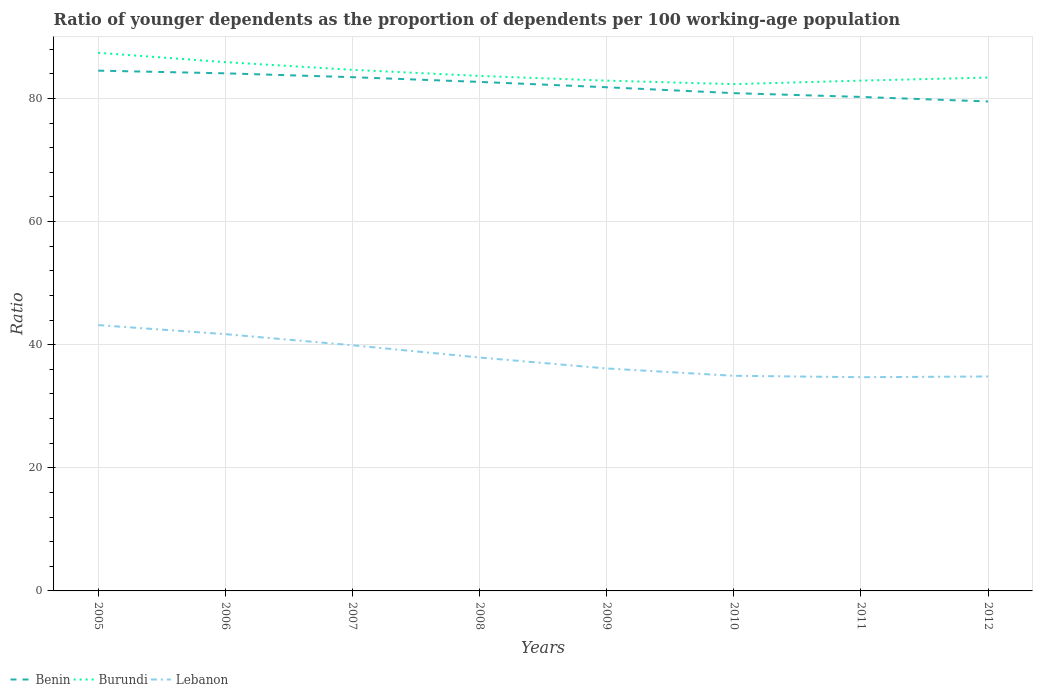Does the line corresponding to Burundi intersect with the line corresponding to Lebanon?
Offer a very short reply. No. Across all years, what is the maximum age dependency ratio(young) in Burundi?
Offer a terse response. 82.32. In which year was the age dependency ratio(young) in Lebanon maximum?
Provide a short and direct response. 2011. What is the total age dependency ratio(young) in Benin in the graph?
Your answer should be very brief. 2.59. What is the difference between the highest and the second highest age dependency ratio(young) in Lebanon?
Provide a succinct answer. 8.46. What is the difference between the highest and the lowest age dependency ratio(young) in Lebanon?
Provide a succinct answer. 3. Is the age dependency ratio(young) in Lebanon strictly greater than the age dependency ratio(young) in Benin over the years?
Provide a succinct answer. Yes. What is the difference between two consecutive major ticks on the Y-axis?
Provide a succinct answer. 20. Are the values on the major ticks of Y-axis written in scientific E-notation?
Offer a very short reply. No. Does the graph contain any zero values?
Your answer should be very brief. No. Does the graph contain grids?
Provide a short and direct response. Yes. How many legend labels are there?
Provide a succinct answer. 3. What is the title of the graph?
Give a very brief answer. Ratio of younger dependents as the proportion of dependents per 100 working-age population. What is the label or title of the Y-axis?
Your response must be concise. Ratio. What is the Ratio of Benin in 2005?
Make the answer very short. 84.52. What is the Ratio of Burundi in 2005?
Provide a succinct answer. 87.41. What is the Ratio in Lebanon in 2005?
Provide a succinct answer. 43.18. What is the Ratio in Benin in 2006?
Offer a terse response. 84.08. What is the Ratio in Burundi in 2006?
Give a very brief answer. 85.9. What is the Ratio of Lebanon in 2006?
Ensure brevity in your answer.  41.71. What is the Ratio in Benin in 2007?
Provide a short and direct response. 83.45. What is the Ratio of Burundi in 2007?
Offer a very short reply. 84.65. What is the Ratio of Lebanon in 2007?
Offer a very short reply. 39.9. What is the Ratio in Benin in 2008?
Ensure brevity in your answer.  82.69. What is the Ratio in Burundi in 2008?
Ensure brevity in your answer.  83.66. What is the Ratio in Lebanon in 2008?
Offer a very short reply. 37.92. What is the Ratio in Benin in 2009?
Your answer should be very brief. 81.81. What is the Ratio in Burundi in 2009?
Ensure brevity in your answer.  82.89. What is the Ratio of Lebanon in 2009?
Ensure brevity in your answer.  36.14. What is the Ratio of Benin in 2010?
Provide a short and direct response. 80.86. What is the Ratio of Burundi in 2010?
Make the answer very short. 82.32. What is the Ratio of Lebanon in 2010?
Give a very brief answer. 34.94. What is the Ratio in Benin in 2011?
Offer a very short reply. 80.25. What is the Ratio in Burundi in 2011?
Keep it short and to the point. 82.89. What is the Ratio of Lebanon in 2011?
Offer a very short reply. 34.72. What is the Ratio in Benin in 2012?
Offer a very short reply. 79.51. What is the Ratio of Burundi in 2012?
Offer a very short reply. 83.39. What is the Ratio of Lebanon in 2012?
Offer a very short reply. 34.83. Across all years, what is the maximum Ratio in Benin?
Provide a short and direct response. 84.52. Across all years, what is the maximum Ratio in Burundi?
Your answer should be very brief. 87.41. Across all years, what is the maximum Ratio of Lebanon?
Offer a very short reply. 43.18. Across all years, what is the minimum Ratio in Benin?
Offer a terse response. 79.51. Across all years, what is the minimum Ratio in Burundi?
Provide a short and direct response. 82.32. Across all years, what is the minimum Ratio of Lebanon?
Keep it short and to the point. 34.72. What is the total Ratio of Benin in the graph?
Offer a terse response. 657.16. What is the total Ratio in Burundi in the graph?
Your response must be concise. 673.11. What is the total Ratio of Lebanon in the graph?
Your answer should be very brief. 303.34. What is the difference between the Ratio of Benin in 2005 and that in 2006?
Make the answer very short. 0.44. What is the difference between the Ratio of Burundi in 2005 and that in 2006?
Your answer should be very brief. 1.52. What is the difference between the Ratio of Lebanon in 2005 and that in 2006?
Provide a succinct answer. 1.47. What is the difference between the Ratio in Benin in 2005 and that in 2007?
Keep it short and to the point. 1.06. What is the difference between the Ratio in Burundi in 2005 and that in 2007?
Give a very brief answer. 2.77. What is the difference between the Ratio in Lebanon in 2005 and that in 2007?
Offer a very short reply. 3.28. What is the difference between the Ratio in Benin in 2005 and that in 2008?
Provide a short and direct response. 1.83. What is the difference between the Ratio in Burundi in 2005 and that in 2008?
Make the answer very short. 3.76. What is the difference between the Ratio of Lebanon in 2005 and that in 2008?
Offer a very short reply. 5.26. What is the difference between the Ratio of Benin in 2005 and that in 2009?
Your response must be concise. 2.7. What is the difference between the Ratio of Burundi in 2005 and that in 2009?
Make the answer very short. 4.52. What is the difference between the Ratio in Lebanon in 2005 and that in 2009?
Keep it short and to the point. 7.04. What is the difference between the Ratio in Benin in 2005 and that in 2010?
Provide a short and direct response. 3.65. What is the difference between the Ratio of Burundi in 2005 and that in 2010?
Offer a very short reply. 5.09. What is the difference between the Ratio of Lebanon in 2005 and that in 2010?
Provide a short and direct response. 8.24. What is the difference between the Ratio in Benin in 2005 and that in 2011?
Ensure brevity in your answer.  4.27. What is the difference between the Ratio in Burundi in 2005 and that in 2011?
Provide a short and direct response. 4.52. What is the difference between the Ratio in Lebanon in 2005 and that in 2011?
Your answer should be compact. 8.46. What is the difference between the Ratio of Benin in 2005 and that in 2012?
Provide a short and direct response. 5.01. What is the difference between the Ratio of Burundi in 2005 and that in 2012?
Make the answer very short. 4.02. What is the difference between the Ratio in Lebanon in 2005 and that in 2012?
Offer a terse response. 8.35. What is the difference between the Ratio in Benin in 2006 and that in 2007?
Your answer should be compact. 0.62. What is the difference between the Ratio of Burundi in 2006 and that in 2007?
Your answer should be very brief. 1.25. What is the difference between the Ratio of Lebanon in 2006 and that in 2007?
Provide a succinct answer. 1.81. What is the difference between the Ratio of Benin in 2006 and that in 2008?
Give a very brief answer. 1.39. What is the difference between the Ratio in Burundi in 2006 and that in 2008?
Provide a succinct answer. 2.24. What is the difference between the Ratio of Lebanon in 2006 and that in 2008?
Your answer should be very brief. 3.79. What is the difference between the Ratio of Benin in 2006 and that in 2009?
Make the answer very short. 2.26. What is the difference between the Ratio in Burundi in 2006 and that in 2009?
Offer a very short reply. 3.01. What is the difference between the Ratio of Lebanon in 2006 and that in 2009?
Offer a very short reply. 5.57. What is the difference between the Ratio of Benin in 2006 and that in 2010?
Offer a terse response. 3.22. What is the difference between the Ratio in Burundi in 2006 and that in 2010?
Offer a terse response. 3.58. What is the difference between the Ratio of Lebanon in 2006 and that in 2010?
Offer a terse response. 6.77. What is the difference between the Ratio of Benin in 2006 and that in 2011?
Ensure brevity in your answer.  3.83. What is the difference between the Ratio in Burundi in 2006 and that in 2011?
Ensure brevity in your answer.  3. What is the difference between the Ratio of Lebanon in 2006 and that in 2011?
Give a very brief answer. 6.99. What is the difference between the Ratio of Benin in 2006 and that in 2012?
Provide a short and direct response. 4.57. What is the difference between the Ratio in Burundi in 2006 and that in 2012?
Make the answer very short. 2.5. What is the difference between the Ratio in Lebanon in 2006 and that in 2012?
Give a very brief answer. 6.88. What is the difference between the Ratio in Benin in 2007 and that in 2008?
Your answer should be very brief. 0.77. What is the difference between the Ratio of Burundi in 2007 and that in 2008?
Make the answer very short. 0.99. What is the difference between the Ratio in Lebanon in 2007 and that in 2008?
Offer a very short reply. 1.99. What is the difference between the Ratio of Benin in 2007 and that in 2009?
Offer a very short reply. 1.64. What is the difference between the Ratio in Burundi in 2007 and that in 2009?
Give a very brief answer. 1.76. What is the difference between the Ratio in Lebanon in 2007 and that in 2009?
Keep it short and to the point. 3.77. What is the difference between the Ratio in Benin in 2007 and that in 2010?
Your answer should be very brief. 2.59. What is the difference between the Ratio in Burundi in 2007 and that in 2010?
Offer a very short reply. 2.32. What is the difference between the Ratio in Lebanon in 2007 and that in 2010?
Keep it short and to the point. 4.96. What is the difference between the Ratio in Benin in 2007 and that in 2011?
Make the answer very short. 3.21. What is the difference between the Ratio of Burundi in 2007 and that in 2011?
Ensure brevity in your answer.  1.75. What is the difference between the Ratio of Lebanon in 2007 and that in 2011?
Ensure brevity in your answer.  5.19. What is the difference between the Ratio of Benin in 2007 and that in 2012?
Your answer should be very brief. 3.95. What is the difference between the Ratio in Burundi in 2007 and that in 2012?
Make the answer very short. 1.25. What is the difference between the Ratio in Lebanon in 2007 and that in 2012?
Make the answer very short. 5.07. What is the difference between the Ratio in Benin in 2008 and that in 2009?
Give a very brief answer. 0.87. What is the difference between the Ratio of Burundi in 2008 and that in 2009?
Your answer should be compact. 0.77. What is the difference between the Ratio of Lebanon in 2008 and that in 2009?
Provide a succinct answer. 1.78. What is the difference between the Ratio in Benin in 2008 and that in 2010?
Your answer should be very brief. 1.83. What is the difference between the Ratio of Burundi in 2008 and that in 2010?
Your answer should be very brief. 1.33. What is the difference between the Ratio of Lebanon in 2008 and that in 2010?
Your response must be concise. 2.97. What is the difference between the Ratio of Benin in 2008 and that in 2011?
Ensure brevity in your answer.  2.44. What is the difference between the Ratio of Burundi in 2008 and that in 2011?
Make the answer very short. 0.76. What is the difference between the Ratio of Lebanon in 2008 and that in 2011?
Offer a terse response. 3.2. What is the difference between the Ratio in Benin in 2008 and that in 2012?
Ensure brevity in your answer.  3.18. What is the difference between the Ratio of Burundi in 2008 and that in 2012?
Keep it short and to the point. 0.26. What is the difference between the Ratio of Lebanon in 2008 and that in 2012?
Your answer should be very brief. 3.08. What is the difference between the Ratio in Benin in 2009 and that in 2010?
Provide a succinct answer. 0.95. What is the difference between the Ratio of Burundi in 2009 and that in 2010?
Offer a very short reply. 0.57. What is the difference between the Ratio in Lebanon in 2009 and that in 2010?
Offer a terse response. 1.19. What is the difference between the Ratio of Benin in 2009 and that in 2011?
Offer a very short reply. 1.57. What is the difference between the Ratio in Burundi in 2009 and that in 2011?
Provide a short and direct response. -0. What is the difference between the Ratio in Lebanon in 2009 and that in 2011?
Your answer should be compact. 1.42. What is the difference between the Ratio in Benin in 2009 and that in 2012?
Give a very brief answer. 2.31. What is the difference between the Ratio of Burundi in 2009 and that in 2012?
Your answer should be compact. -0.5. What is the difference between the Ratio of Lebanon in 2009 and that in 2012?
Ensure brevity in your answer.  1.3. What is the difference between the Ratio of Benin in 2010 and that in 2011?
Make the answer very short. 0.62. What is the difference between the Ratio in Burundi in 2010 and that in 2011?
Offer a terse response. -0.57. What is the difference between the Ratio in Lebanon in 2010 and that in 2011?
Your response must be concise. 0.23. What is the difference between the Ratio of Benin in 2010 and that in 2012?
Your response must be concise. 1.35. What is the difference between the Ratio in Burundi in 2010 and that in 2012?
Offer a terse response. -1.07. What is the difference between the Ratio of Lebanon in 2010 and that in 2012?
Make the answer very short. 0.11. What is the difference between the Ratio of Benin in 2011 and that in 2012?
Offer a very short reply. 0.74. What is the difference between the Ratio in Burundi in 2011 and that in 2012?
Offer a terse response. -0.5. What is the difference between the Ratio in Lebanon in 2011 and that in 2012?
Keep it short and to the point. -0.12. What is the difference between the Ratio of Benin in 2005 and the Ratio of Burundi in 2006?
Make the answer very short. -1.38. What is the difference between the Ratio of Benin in 2005 and the Ratio of Lebanon in 2006?
Your response must be concise. 42.81. What is the difference between the Ratio in Burundi in 2005 and the Ratio in Lebanon in 2006?
Your response must be concise. 45.7. What is the difference between the Ratio of Benin in 2005 and the Ratio of Burundi in 2007?
Provide a succinct answer. -0.13. What is the difference between the Ratio of Benin in 2005 and the Ratio of Lebanon in 2007?
Your response must be concise. 44.61. What is the difference between the Ratio in Burundi in 2005 and the Ratio in Lebanon in 2007?
Provide a short and direct response. 47.51. What is the difference between the Ratio in Benin in 2005 and the Ratio in Burundi in 2008?
Your response must be concise. 0.86. What is the difference between the Ratio of Benin in 2005 and the Ratio of Lebanon in 2008?
Provide a short and direct response. 46.6. What is the difference between the Ratio in Burundi in 2005 and the Ratio in Lebanon in 2008?
Your response must be concise. 49.5. What is the difference between the Ratio in Benin in 2005 and the Ratio in Burundi in 2009?
Provide a succinct answer. 1.63. What is the difference between the Ratio in Benin in 2005 and the Ratio in Lebanon in 2009?
Provide a short and direct response. 48.38. What is the difference between the Ratio of Burundi in 2005 and the Ratio of Lebanon in 2009?
Ensure brevity in your answer.  51.28. What is the difference between the Ratio in Benin in 2005 and the Ratio in Burundi in 2010?
Your answer should be very brief. 2.19. What is the difference between the Ratio of Benin in 2005 and the Ratio of Lebanon in 2010?
Your answer should be compact. 49.57. What is the difference between the Ratio of Burundi in 2005 and the Ratio of Lebanon in 2010?
Your response must be concise. 52.47. What is the difference between the Ratio in Benin in 2005 and the Ratio in Burundi in 2011?
Keep it short and to the point. 1.62. What is the difference between the Ratio in Benin in 2005 and the Ratio in Lebanon in 2011?
Offer a very short reply. 49.8. What is the difference between the Ratio in Burundi in 2005 and the Ratio in Lebanon in 2011?
Offer a terse response. 52.7. What is the difference between the Ratio of Benin in 2005 and the Ratio of Burundi in 2012?
Keep it short and to the point. 1.12. What is the difference between the Ratio in Benin in 2005 and the Ratio in Lebanon in 2012?
Provide a succinct answer. 49.68. What is the difference between the Ratio in Burundi in 2005 and the Ratio in Lebanon in 2012?
Provide a succinct answer. 52.58. What is the difference between the Ratio in Benin in 2006 and the Ratio in Burundi in 2007?
Keep it short and to the point. -0.57. What is the difference between the Ratio in Benin in 2006 and the Ratio in Lebanon in 2007?
Offer a very short reply. 44.17. What is the difference between the Ratio in Burundi in 2006 and the Ratio in Lebanon in 2007?
Keep it short and to the point. 45.99. What is the difference between the Ratio in Benin in 2006 and the Ratio in Burundi in 2008?
Provide a succinct answer. 0.42. What is the difference between the Ratio in Benin in 2006 and the Ratio in Lebanon in 2008?
Your answer should be very brief. 46.16. What is the difference between the Ratio in Burundi in 2006 and the Ratio in Lebanon in 2008?
Give a very brief answer. 47.98. What is the difference between the Ratio of Benin in 2006 and the Ratio of Burundi in 2009?
Provide a short and direct response. 1.19. What is the difference between the Ratio of Benin in 2006 and the Ratio of Lebanon in 2009?
Your response must be concise. 47.94. What is the difference between the Ratio in Burundi in 2006 and the Ratio in Lebanon in 2009?
Provide a short and direct response. 49.76. What is the difference between the Ratio in Benin in 2006 and the Ratio in Burundi in 2010?
Give a very brief answer. 1.76. What is the difference between the Ratio in Benin in 2006 and the Ratio in Lebanon in 2010?
Offer a very short reply. 49.13. What is the difference between the Ratio in Burundi in 2006 and the Ratio in Lebanon in 2010?
Make the answer very short. 50.95. What is the difference between the Ratio in Benin in 2006 and the Ratio in Burundi in 2011?
Provide a short and direct response. 1.18. What is the difference between the Ratio in Benin in 2006 and the Ratio in Lebanon in 2011?
Your answer should be very brief. 49.36. What is the difference between the Ratio in Burundi in 2006 and the Ratio in Lebanon in 2011?
Make the answer very short. 51.18. What is the difference between the Ratio of Benin in 2006 and the Ratio of Burundi in 2012?
Your answer should be compact. 0.69. What is the difference between the Ratio in Benin in 2006 and the Ratio in Lebanon in 2012?
Offer a terse response. 49.25. What is the difference between the Ratio of Burundi in 2006 and the Ratio of Lebanon in 2012?
Offer a very short reply. 51.06. What is the difference between the Ratio in Benin in 2007 and the Ratio in Burundi in 2008?
Ensure brevity in your answer.  -0.2. What is the difference between the Ratio in Benin in 2007 and the Ratio in Lebanon in 2008?
Your answer should be very brief. 45.54. What is the difference between the Ratio in Burundi in 2007 and the Ratio in Lebanon in 2008?
Provide a short and direct response. 46.73. What is the difference between the Ratio in Benin in 2007 and the Ratio in Burundi in 2009?
Give a very brief answer. 0.56. What is the difference between the Ratio in Benin in 2007 and the Ratio in Lebanon in 2009?
Your answer should be very brief. 47.32. What is the difference between the Ratio in Burundi in 2007 and the Ratio in Lebanon in 2009?
Your answer should be very brief. 48.51. What is the difference between the Ratio of Benin in 2007 and the Ratio of Burundi in 2010?
Offer a very short reply. 1.13. What is the difference between the Ratio of Benin in 2007 and the Ratio of Lebanon in 2010?
Give a very brief answer. 48.51. What is the difference between the Ratio of Burundi in 2007 and the Ratio of Lebanon in 2010?
Your answer should be very brief. 49.7. What is the difference between the Ratio of Benin in 2007 and the Ratio of Burundi in 2011?
Provide a succinct answer. 0.56. What is the difference between the Ratio in Benin in 2007 and the Ratio in Lebanon in 2011?
Provide a succinct answer. 48.74. What is the difference between the Ratio in Burundi in 2007 and the Ratio in Lebanon in 2011?
Keep it short and to the point. 49.93. What is the difference between the Ratio in Benin in 2007 and the Ratio in Burundi in 2012?
Your response must be concise. 0.06. What is the difference between the Ratio of Benin in 2007 and the Ratio of Lebanon in 2012?
Provide a short and direct response. 48.62. What is the difference between the Ratio of Burundi in 2007 and the Ratio of Lebanon in 2012?
Make the answer very short. 49.81. What is the difference between the Ratio of Benin in 2008 and the Ratio of Burundi in 2009?
Keep it short and to the point. -0.2. What is the difference between the Ratio in Benin in 2008 and the Ratio in Lebanon in 2009?
Your answer should be compact. 46.55. What is the difference between the Ratio of Burundi in 2008 and the Ratio of Lebanon in 2009?
Ensure brevity in your answer.  47.52. What is the difference between the Ratio of Benin in 2008 and the Ratio of Burundi in 2010?
Ensure brevity in your answer.  0.36. What is the difference between the Ratio in Benin in 2008 and the Ratio in Lebanon in 2010?
Ensure brevity in your answer.  47.74. What is the difference between the Ratio in Burundi in 2008 and the Ratio in Lebanon in 2010?
Your response must be concise. 48.71. What is the difference between the Ratio in Benin in 2008 and the Ratio in Burundi in 2011?
Offer a terse response. -0.21. What is the difference between the Ratio in Benin in 2008 and the Ratio in Lebanon in 2011?
Your answer should be very brief. 47.97. What is the difference between the Ratio of Burundi in 2008 and the Ratio of Lebanon in 2011?
Your answer should be compact. 48.94. What is the difference between the Ratio in Benin in 2008 and the Ratio in Burundi in 2012?
Provide a succinct answer. -0.71. What is the difference between the Ratio in Benin in 2008 and the Ratio in Lebanon in 2012?
Provide a short and direct response. 47.85. What is the difference between the Ratio of Burundi in 2008 and the Ratio of Lebanon in 2012?
Give a very brief answer. 48.82. What is the difference between the Ratio of Benin in 2009 and the Ratio of Burundi in 2010?
Keep it short and to the point. -0.51. What is the difference between the Ratio in Benin in 2009 and the Ratio in Lebanon in 2010?
Your answer should be very brief. 46.87. What is the difference between the Ratio of Burundi in 2009 and the Ratio of Lebanon in 2010?
Make the answer very short. 47.95. What is the difference between the Ratio in Benin in 2009 and the Ratio in Burundi in 2011?
Make the answer very short. -1.08. What is the difference between the Ratio of Benin in 2009 and the Ratio of Lebanon in 2011?
Provide a short and direct response. 47.1. What is the difference between the Ratio of Burundi in 2009 and the Ratio of Lebanon in 2011?
Offer a very short reply. 48.17. What is the difference between the Ratio in Benin in 2009 and the Ratio in Burundi in 2012?
Keep it short and to the point. -1.58. What is the difference between the Ratio in Benin in 2009 and the Ratio in Lebanon in 2012?
Offer a terse response. 46.98. What is the difference between the Ratio of Burundi in 2009 and the Ratio of Lebanon in 2012?
Keep it short and to the point. 48.06. What is the difference between the Ratio in Benin in 2010 and the Ratio in Burundi in 2011?
Your answer should be very brief. -2.03. What is the difference between the Ratio of Benin in 2010 and the Ratio of Lebanon in 2011?
Your answer should be compact. 46.14. What is the difference between the Ratio in Burundi in 2010 and the Ratio in Lebanon in 2011?
Your answer should be compact. 47.6. What is the difference between the Ratio in Benin in 2010 and the Ratio in Burundi in 2012?
Your answer should be very brief. -2.53. What is the difference between the Ratio in Benin in 2010 and the Ratio in Lebanon in 2012?
Your answer should be compact. 46.03. What is the difference between the Ratio in Burundi in 2010 and the Ratio in Lebanon in 2012?
Provide a succinct answer. 47.49. What is the difference between the Ratio of Benin in 2011 and the Ratio of Burundi in 2012?
Your response must be concise. -3.15. What is the difference between the Ratio of Benin in 2011 and the Ratio of Lebanon in 2012?
Provide a short and direct response. 45.41. What is the difference between the Ratio in Burundi in 2011 and the Ratio in Lebanon in 2012?
Your response must be concise. 48.06. What is the average Ratio in Benin per year?
Provide a short and direct response. 82.14. What is the average Ratio in Burundi per year?
Make the answer very short. 84.14. What is the average Ratio of Lebanon per year?
Keep it short and to the point. 37.92. In the year 2005, what is the difference between the Ratio of Benin and Ratio of Burundi?
Your answer should be very brief. -2.9. In the year 2005, what is the difference between the Ratio in Benin and Ratio in Lebanon?
Make the answer very short. 41.33. In the year 2005, what is the difference between the Ratio in Burundi and Ratio in Lebanon?
Your answer should be compact. 44.23. In the year 2006, what is the difference between the Ratio in Benin and Ratio in Burundi?
Your answer should be compact. -1.82. In the year 2006, what is the difference between the Ratio of Benin and Ratio of Lebanon?
Keep it short and to the point. 42.37. In the year 2006, what is the difference between the Ratio in Burundi and Ratio in Lebanon?
Your answer should be very brief. 44.19. In the year 2007, what is the difference between the Ratio of Benin and Ratio of Burundi?
Your answer should be compact. -1.19. In the year 2007, what is the difference between the Ratio of Benin and Ratio of Lebanon?
Keep it short and to the point. 43.55. In the year 2007, what is the difference between the Ratio of Burundi and Ratio of Lebanon?
Offer a terse response. 44.74. In the year 2008, what is the difference between the Ratio of Benin and Ratio of Burundi?
Keep it short and to the point. -0.97. In the year 2008, what is the difference between the Ratio in Benin and Ratio in Lebanon?
Make the answer very short. 44.77. In the year 2008, what is the difference between the Ratio in Burundi and Ratio in Lebanon?
Make the answer very short. 45.74. In the year 2009, what is the difference between the Ratio in Benin and Ratio in Burundi?
Offer a very short reply. -1.08. In the year 2009, what is the difference between the Ratio in Benin and Ratio in Lebanon?
Give a very brief answer. 45.68. In the year 2009, what is the difference between the Ratio of Burundi and Ratio of Lebanon?
Offer a terse response. 46.75. In the year 2010, what is the difference between the Ratio in Benin and Ratio in Burundi?
Give a very brief answer. -1.46. In the year 2010, what is the difference between the Ratio of Benin and Ratio of Lebanon?
Provide a short and direct response. 45.92. In the year 2010, what is the difference between the Ratio in Burundi and Ratio in Lebanon?
Provide a succinct answer. 47.38. In the year 2011, what is the difference between the Ratio in Benin and Ratio in Burundi?
Provide a succinct answer. -2.65. In the year 2011, what is the difference between the Ratio of Benin and Ratio of Lebanon?
Make the answer very short. 45.53. In the year 2011, what is the difference between the Ratio of Burundi and Ratio of Lebanon?
Offer a terse response. 48.18. In the year 2012, what is the difference between the Ratio of Benin and Ratio of Burundi?
Give a very brief answer. -3.89. In the year 2012, what is the difference between the Ratio in Benin and Ratio in Lebanon?
Give a very brief answer. 44.67. In the year 2012, what is the difference between the Ratio in Burundi and Ratio in Lebanon?
Provide a succinct answer. 48.56. What is the ratio of the Ratio of Burundi in 2005 to that in 2006?
Make the answer very short. 1.02. What is the ratio of the Ratio of Lebanon in 2005 to that in 2006?
Your answer should be compact. 1.04. What is the ratio of the Ratio of Benin in 2005 to that in 2007?
Give a very brief answer. 1.01. What is the ratio of the Ratio in Burundi in 2005 to that in 2007?
Provide a short and direct response. 1.03. What is the ratio of the Ratio in Lebanon in 2005 to that in 2007?
Give a very brief answer. 1.08. What is the ratio of the Ratio in Benin in 2005 to that in 2008?
Offer a terse response. 1.02. What is the ratio of the Ratio of Burundi in 2005 to that in 2008?
Provide a succinct answer. 1.04. What is the ratio of the Ratio of Lebanon in 2005 to that in 2008?
Keep it short and to the point. 1.14. What is the ratio of the Ratio of Benin in 2005 to that in 2009?
Provide a succinct answer. 1.03. What is the ratio of the Ratio in Burundi in 2005 to that in 2009?
Your answer should be very brief. 1.05. What is the ratio of the Ratio in Lebanon in 2005 to that in 2009?
Offer a terse response. 1.19. What is the ratio of the Ratio of Benin in 2005 to that in 2010?
Offer a very short reply. 1.05. What is the ratio of the Ratio in Burundi in 2005 to that in 2010?
Your response must be concise. 1.06. What is the ratio of the Ratio in Lebanon in 2005 to that in 2010?
Your response must be concise. 1.24. What is the ratio of the Ratio of Benin in 2005 to that in 2011?
Keep it short and to the point. 1.05. What is the ratio of the Ratio in Burundi in 2005 to that in 2011?
Give a very brief answer. 1.05. What is the ratio of the Ratio of Lebanon in 2005 to that in 2011?
Give a very brief answer. 1.24. What is the ratio of the Ratio of Benin in 2005 to that in 2012?
Ensure brevity in your answer.  1.06. What is the ratio of the Ratio in Burundi in 2005 to that in 2012?
Offer a very short reply. 1.05. What is the ratio of the Ratio of Lebanon in 2005 to that in 2012?
Provide a succinct answer. 1.24. What is the ratio of the Ratio of Benin in 2006 to that in 2007?
Give a very brief answer. 1.01. What is the ratio of the Ratio of Burundi in 2006 to that in 2007?
Offer a terse response. 1.01. What is the ratio of the Ratio in Lebanon in 2006 to that in 2007?
Give a very brief answer. 1.05. What is the ratio of the Ratio in Benin in 2006 to that in 2008?
Offer a terse response. 1.02. What is the ratio of the Ratio of Burundi in 2006 to that in 2008?
Provide a succinct answer. 1.03. What is the ratio of the Ratio in Lebanon in 2006 to that in 2008?
Make the answer very short. 1.1. What is the ratio of the Ratio in Benin in 2006 to that in 2009?
Your answer should be compact. 1.03. What is the ratio of the Ratio in Burundi in 2006 to that in 2009?
Your answer should be compact. 1.04. What is the ratio of the Ratio in Lebanon in 2006 to that in 2009?
Provide a short and direct response. 1.15. What is the ratio of the Ratio in Benin in 2006 to that in 2010?
Offer a terse response. 1.04. What is the ratio of the Ratio in Burundi in 2006 to that in 2010?
Provide a succinct answer. 1.04. What is the ratio of the Ratio in Lebanon in 2006 to that in 2010?
Make the answer very short. 1.19. What is the ratio of the Ratio in Benin in 2006 to that in 2011?
Your answer should be compact. 1.05. What is the ratio of the Ratio of Burundi in 2006 to that in 2011?
Give a very brief answer. 1.04. What is the ratio of the Ratio of Lebanon in 2006 to that in 2011?
Provide a succinct answer. 1.2. What is the ratio of the Ratio in Benin in 2006 to that in 2012?
Offer a very short reply. 1.06. What is the ratio of the Ratio in Burundi in 2006 to that in 2012?
Provide a succinct answer. 1.03. What is the ratio of the Ratio of Lebanon in 2006 to that in 2012?
Provide a succinct answer. 1.2. What is the ratio of the Ratio of Benin in 2007 to that in 2008?
Your response must be concise. 1.01. What is the ratio of the Ratio in Burundi in 2007 to that in 2008?
Your response must be concise. 1.01. What is the ratio of the Ratio of Lebanon in 2007 to that in 2008?
Offer a terse response. 1.05. What is the ratio of the Ratio of Burundi in 2007 to that in 2009?
Give a very brief answer. 1.02. What is the ratio of the Ratio in Lebanon in 2007 to that in 2009?
Ensure brevity in your answer.  1.1. What is the ratio of the Ratio in Benin in 2007 to that in 2010?
Offer a terse response. 1.03. What is the ratio of the Ratio in Burundi in 2007 to that in 2010?
Your answer should be compact. 1.03. What is the ratio of the Ratio of Lebanon in 2007 to that in 2010?
Your response must be concise. 1.14. What is the ratio of the Ratio of Benin in 2007 to that in 2011?
Give a very brief answer. 1.04. What is the ratio of the Ratio in Burundi in 2007 to that in 2011?
Ensure brevity in your answer.  1.02. What is the ratio of the Ratio in Lebanon in 2007 to that in 2011?
Provide a short and direct response. 1.15. What is the ratio of the Ratio in Benin in 2007 to that in 2012?
Offer a terse response. 1.05. What is the ratio of the Ratio in Burundi in 2007 to that in 2012?
Your answer should be compact. 1.01. What is the ratio of the Ratio of Lebanon in 2007 to that in 2012?
Your answer should be very brief. 1.15. What is the ratio of the Ratio of Benin in 2008 to that in 2009?
Provide a succinct answer. 1.01. What is the ratio of the Ratio in Burundi in 2008 to that in 2009?
Your answer should be compact. 1.01. What is the ratio of the Ratio in Lebanon in 2008 to that in 2009?
Your response must be concise. 1.05. What is the ratio of the Ratio in Benin in 2008 to that in 2010?
Your answer should be very brief. 1.02. What is the ratio of the Ratio in Burundi in 2008 to that in 2010?
Your answer should be compact. 1.02. What is the ratio of the Ratio of Lebanon in 2008 to that in 2010?
Offer a terse response. 1.08. What is the ratio of the Ratio in Benin in 2008 to that in 2011?
Provide a short and direct response. 1.03. What is the ratio of the Ratio in Burundi in 2008 to that in 2011?
Make the answer very short. 1.01. What is the ratio of the Ratio in Lebanon in 2008 to that in 2011?
Your answer should be compact. 1.09. What is the ratio of the Ratio in Benin in 2008 to that in 2012?
Your response must be concise. 1.04. What is the ratio of the Ratio in Lebanon in 2008 to that in 2012?
Provide a short and direct response. 1.09. What is the ratio of the Ratio of Benin in 2009 to that in 2010?
Provide a succinct answer. 1.01. What is the ratio of the Ratio of Lebanon in 2009 to that in 2010?
Keep it short and to the point. 1.03. What is the ratio of the Ratio in Benin in 2009 to that in 2011?
Offer a very short reply. 1.02. What is the ratio of the Ratio of Burundi in 2009 to that in 2011?
Your answer should be compact. 1. What is the ratio of the Ratio in Lebanon in 2009 to that in 2011?
Provide a succinct answer. 1.04. What is the ratio of the Ratio of Lebanon in 2009 to that in 2012?
Provide a succinct answer. 1.04. What is the ratio of the Ratio in Benin in 2010 to that in 2011?
Make the answer very short. 1.01. What is the ratio of the Ratio in Lebanon in 2010 to that in 2011?
Your response must be concise. 1.01. What is the ratio of the Ratio in Benin in 2010 to that in 2012?
Give a very brief answer. 1.02. What is the ratio of the Ratio in Burundi in 2010 to that in 2012?
Your answer should be very brief. 0.99. What is the ratio of the Ratio of Benin in 2011 to that in 2012?
Ensure brevity in your answer.  1.01. What is the difference between the highest and the second highest Ratio in Benin?
Keep it short and to the point. 0.44. What is the difference between the highest and the second highest Ratio of Burundi?
Give a very brief answer. 1.52. What is the difference between the highest and the second highest Ratio of Lebanon?
Your answer should be very brief. 1.47. What is the difference between the highest and the lowest Ratio of Benin?
Keep it short and to the point. 5.01. What is the difference between the highest and the lowest Ratio in Burundi?
Your answer should be very brief. 5.09. What is the difference between the highest and the lowest Ratio in Lebanon?
Offer a terse response. 8.46. 